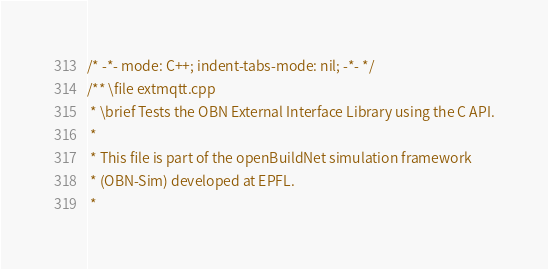<code> <loc_0><loc_0><loc_500><loc_500><_C++_>/* -*- mode: C++; indent-tabs-mode: nil; -*- */
/** \file extmqtt.cpp
 * \brief Tests the OBN External Interface Library using the C API.
 *
 * This file is part of the openBuildNet simulation framework
 * (OBN-Sim) developed at EPFL.
 *</code> 